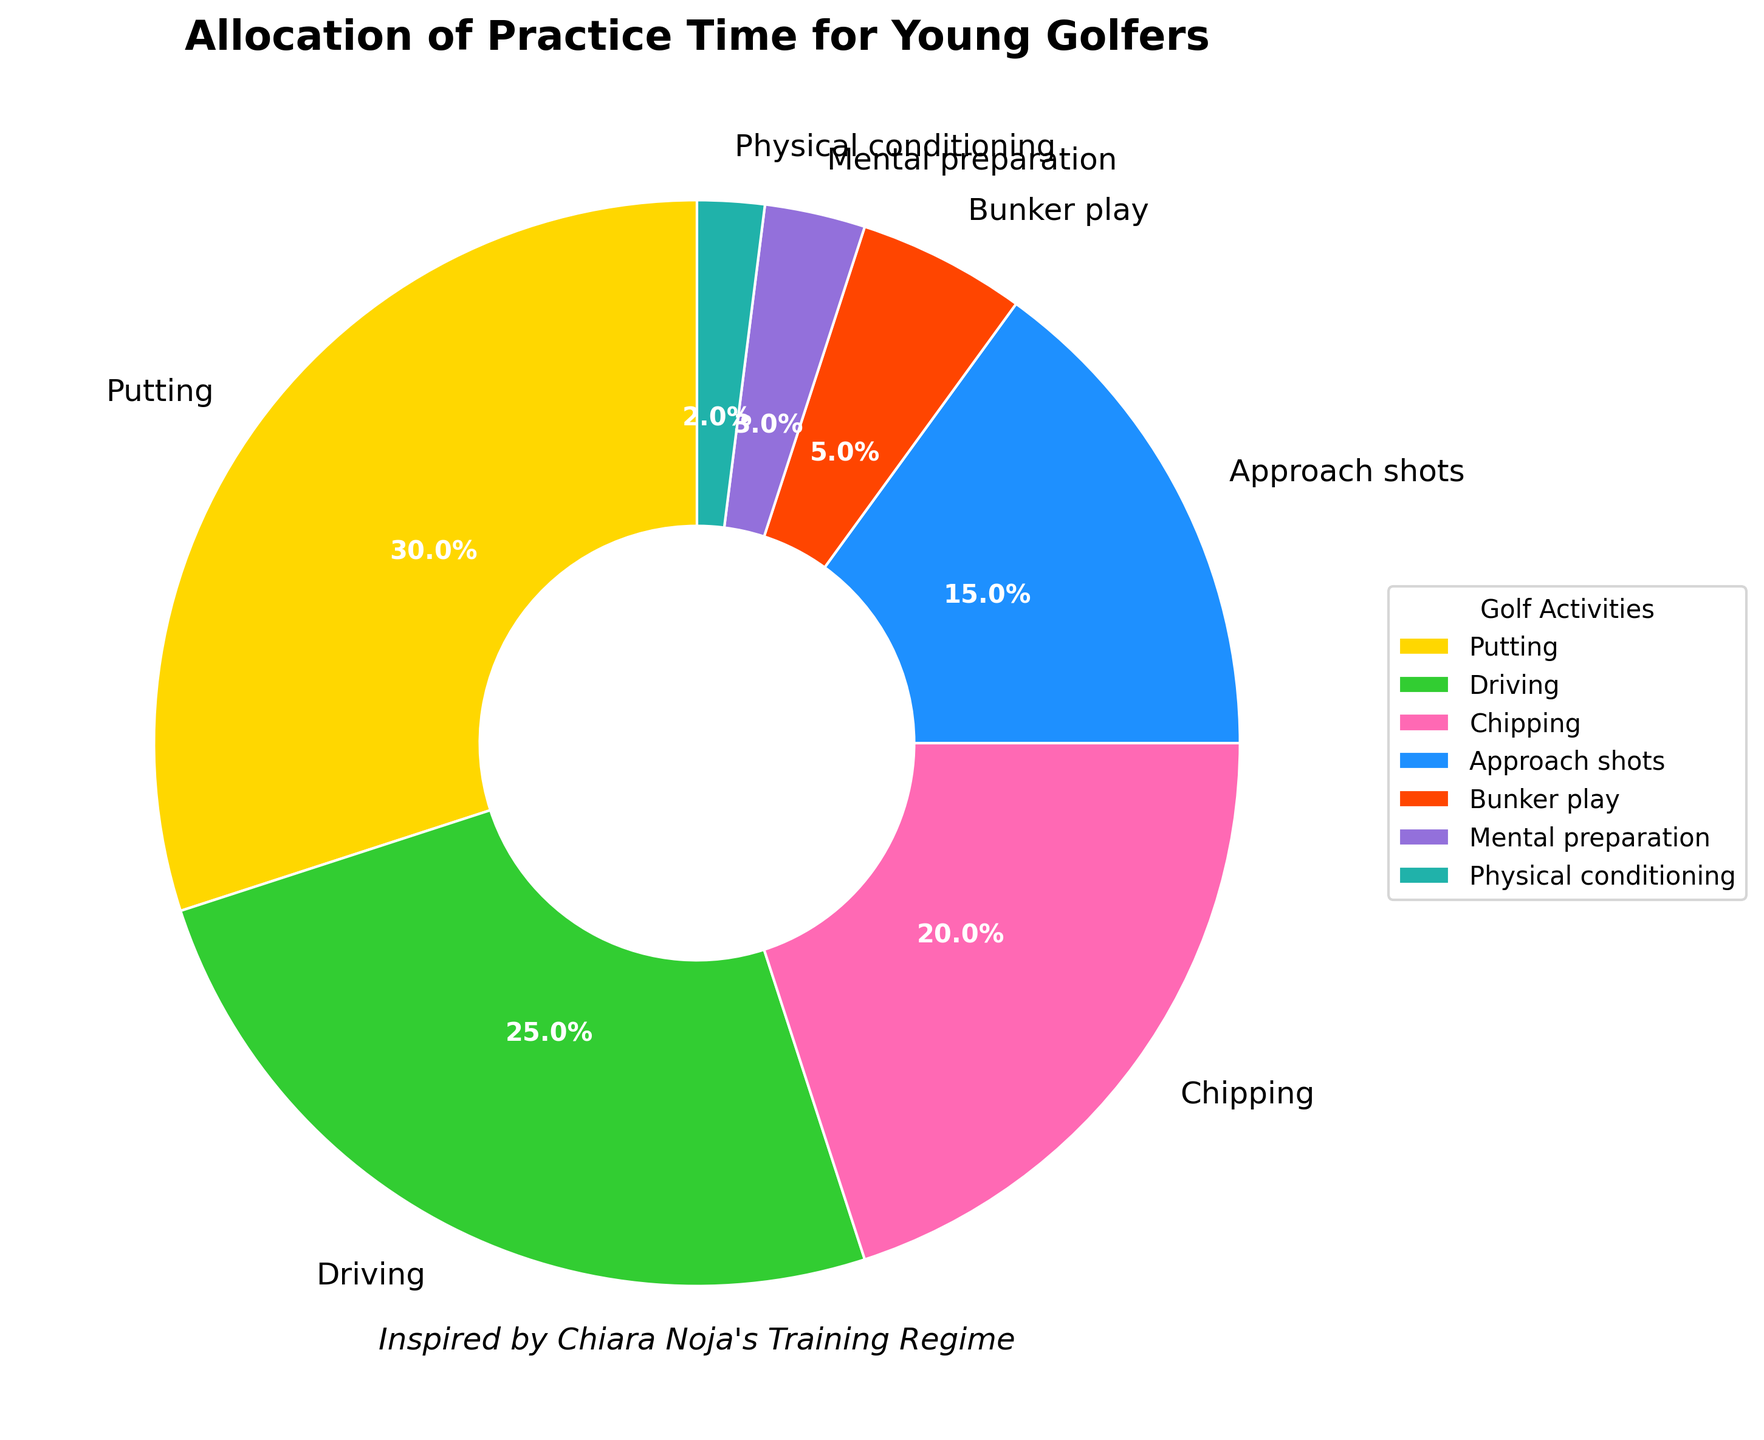Which activity takes up the most practice time? To find this, look at the activity with the largest percentage slice in the pie chart. Putting has the largest percentage (30%).
Answer: Putting How much more time is spent on driving compared to bunker play? Find the percentage for driving (25%) and the percentage for bunker play (5%), then subtract the smaller number from the larger number: 25% - 5% = 20%.
Answer: 20% What is the combined practice time for approach shots and mental preparation? Add the percentages for approach shots (15%) and mental preparation (3%): 15% + 3% = 18%.
Answer: 18% Which activity is practiced the least, and what percentage of time is allocated to it? Identify the smallest slice in the pie chart. Physical conditioning has the smallest percentage (2%).
Answer: Physical conditioning, 2% Is more practice time spent on chipping or mental preparation, and by how much? Compare the percentages for chipping (20%) and mental preparation (3%). Calculate the difference: 20% - 3% = 17%.
Answer: Chipping, 17% Which two activities together make up the majority of practice time? Find two activities whose combined percentage is more than 50%. Putting (30%) and driving (25%) together make 55%, which is more than 50%.
Answer: Putting and driving What fraction of practice time is allocated for bunker play and physical conditioning combined? Add the percentages for bunker play (5%) and physical conditioning (2%), then convert it to a fraction of the total practice time: 5% + 2% = 7%, which is 7/100 or 7%.
Answer: 7% By how much do putting and approach shots combined exceed chipping? Add the percentages for putting (30%) and approach shots (15%), then subtract the percentage for chipping (20%): 30% + 15% = 45%, 45% - 20% = 25%.
Answer: 25% Looking at the colors, which activity is represented by pink, and what percentage of time is spent on it? Identify the color pink in the pie chart and find the corresponding activity and its percentage. Driving is represented by pink (25%).
Answer: Driving, 25% 